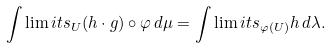<formula> <loc_0><loc_0><loc_500><loc_500>\int \lim i t s _ { U } ( h \cdot g ) \circ \varphi \, d \mu = \int \lim i t s _ { \varphi ( U ) } h \, d \lambda .</formula> 